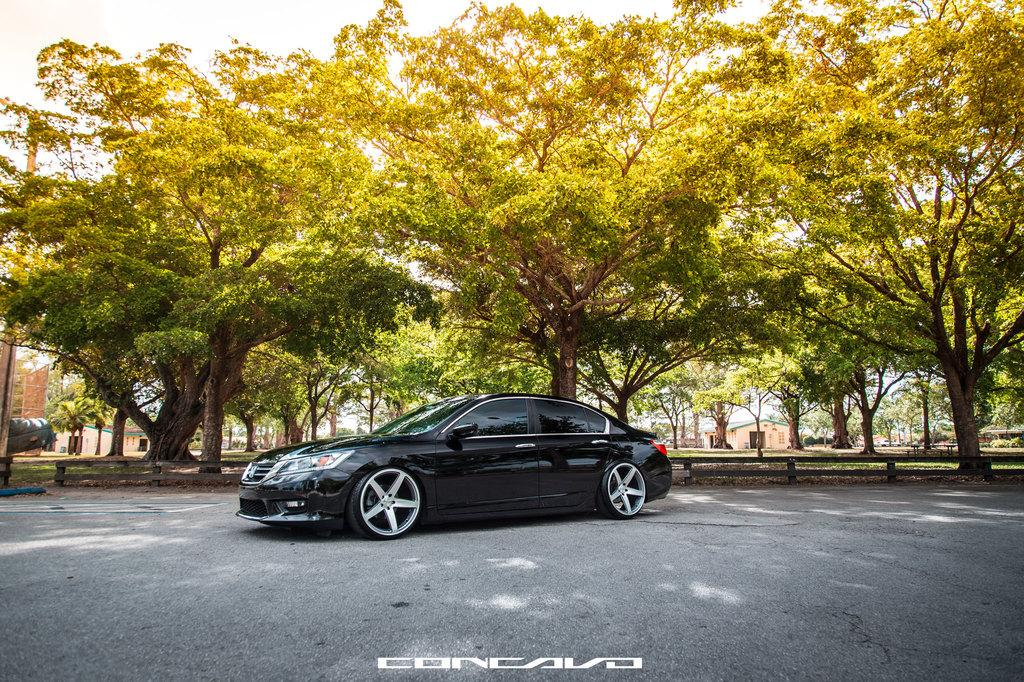What is the main subject of the image? There is a car on the road in the image. Can you describe any text visible in the image? Yes, there is some text visible in the image. What can be seen in the background of the image? There are trees, sheds, and poles in the background of the image. Can you tell me how many snails are crawling on the car in the image? There are no snails visible on the car in the image. Is there a window visible in the image? The image does not show any windows; it features a car on the road with a background of trees, sheds, and poles. 